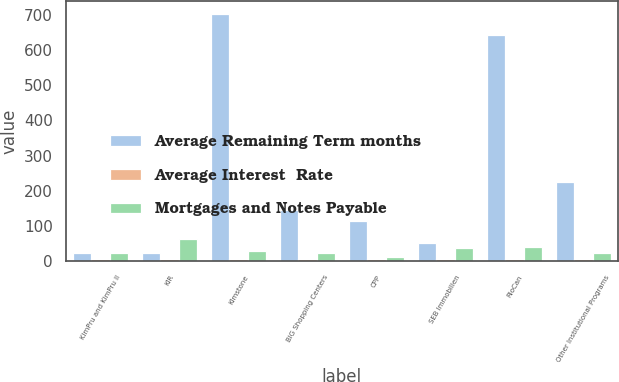Convert chart to OTSL. <chart><loc_0><loc_0><loc_500><loc_500><stacked_bar_chart><ecel><fcel>KimPru and KimPru II<fcel>KIR<fcel>Kimstone<fcel>BIG Shopping Centers<fcel>CPP<fcel>SEB Immobilien<fcel>RioCan<fcel>Other Institutional Programs<nl><fcel>Average Remaining Term months<fcel>22.5<fcel>22.5<fcel>704.4<fcel>144.6<fcel>112.1<fcel>50.2<fcel>642.6<fcel>223.1<nl><fcel>Average Interest  Rate<fcel>5.53<fcel>5.04<fcel>4.45<fcel>5.52<fcel>5.05<fcel>4.06<fcel>4.29<fcel>5.47<nl><fcel>Mortgages and Notes Payable<fcel>23<fcel>61.9<fcel>28.7<fcel>22<fcel>10.1<fcel>35.7<fcel>39.9<fcel>20.8<nl></chart> 